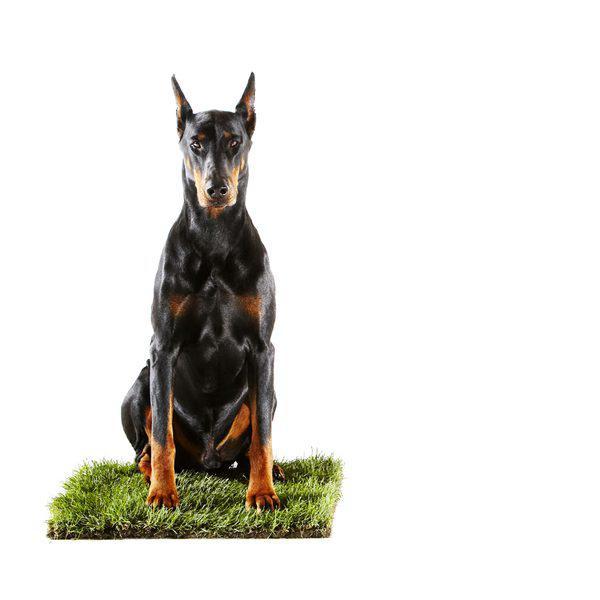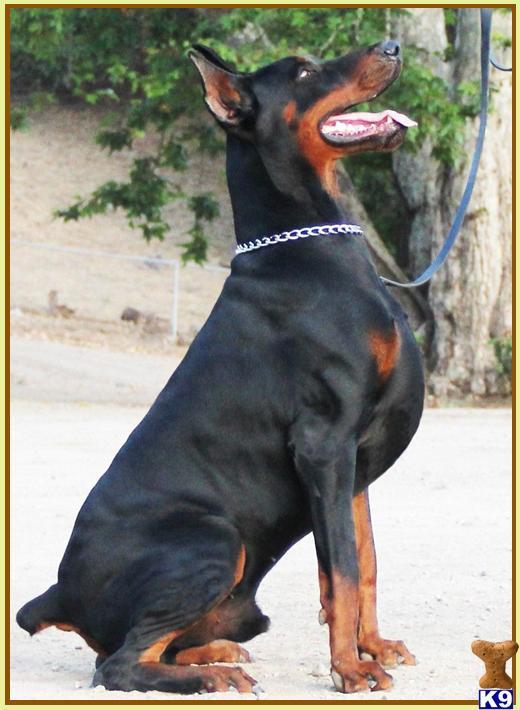The first image is the image on the left, the second image is the image on the right. Evaluate the accuracy of this statement regarding the images: "One image contains a doberman sitting upright with its body turned leftward, and the other image features a doberman sitting upright with one front paw raised.". Is it true? Answer yes or no. No. The first image is the image on the left, the second image is the image on the right. For the images shown, is this caption "A dog has one paw off the ground." true? Answer yes or no. No. 